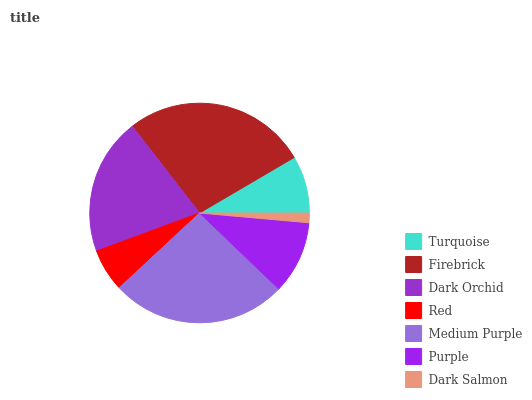Is Dark Salmon the minimum?
Answer yes or no. Yes. Is Firebrick the maximum?
Answer yes or no. Yes. Is Dark Orchid the minimum?
Answer yes or no. No. Is Dark Orchid the maximum?
Answer yes or no. No. Is Firebrick greater than Dark Orchid?
Answer yes or no. Yes. Is Dark Orchid less than Firebrick?
Answer yes or no. Yes. Is Dark Orchid greater than Firebrick?
Answer yes or no. No. Is Firebrick less than Dark Orchid?
Answer yes or no. No. Is Purple the high median?
Answer yes or no. Yes. Is Purple the low median?
Answer yes or no. Yes. Is Dark Orchid the high median?
Answer yes or no. No. Is Red the low median?
Answer yes or no. No. 